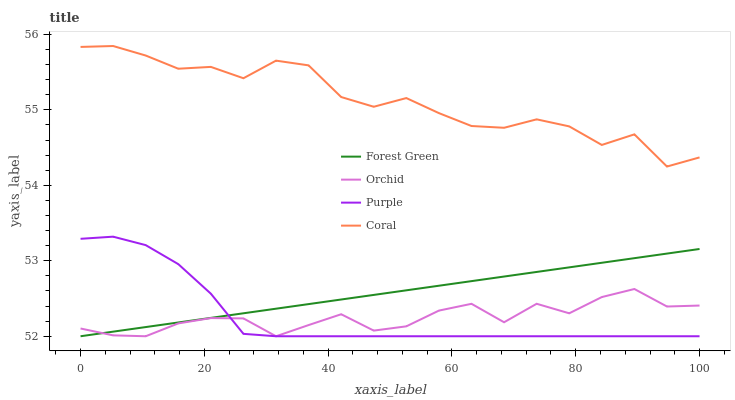Does Purple have the minimum area under the curve?
Answer yes or no. Yes. Does Coral have the maximum area under the curve?
Answer yes or no. Yes. Does Forest Green have the minimum area under the curve?
Answer yes or no. No. Does Forest Green have the maximum area under the curve?
Answer yes or no. No. Is Forest Green the smoothest?
Answer yes or no. Yes. Is Coral the roughest?
Answer yes or no. Yes. Is Coral the smoothest?
Answer yes or no. No. Is Forest Green the roughest?
Answer yes or no. No. Does Purple have the lowest value?
Answer yes or no. Yes. Does Coral have the lowest value?
Answer yes or no. No. Does Coral have the highest value?
Answer yes or no. Yes. Does Forest Green have the highest value?
Answer yes or no. No. Is Orchid less than Coral?
Answer yes or no. Yes. Is Coral greater than Forest Green?
Answer yes or no. Yes. Does Purple intersect Orchid?
Answer yes or no. Yes. Is Purple less than Orchid?
Answer yes or no. No. Is Purple greater than Orchid?
Answer yes or no. No. Does Orchid intersect Coral?
Answer yes or no. No. 